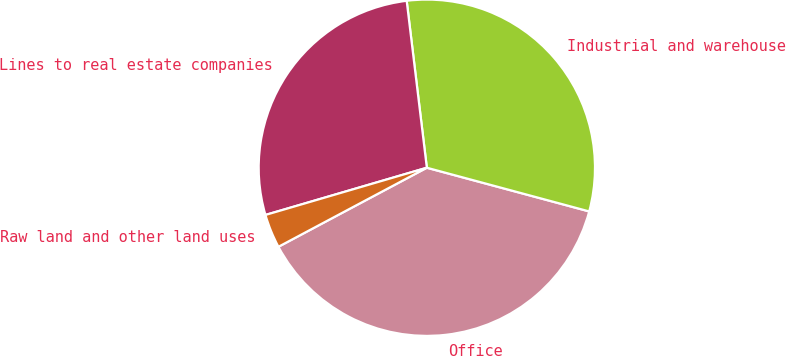Convert chart. <chart><loc_0><loc_0><loc_500><loc_500><pie_chart><fcel>Office<fcel>Industrial and warehouse<fcel>Lines to real estate companies<fcel>Raw land and other land uses<nl><fcel>38.03%<fcel>31.1%<fcel>27.62%<fcel>3.26%<nl></chart> 